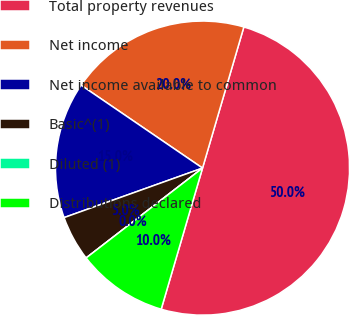<chart> <loc_0><loc_0><loc_500><loc_500><pie_chart><fcel>Total property revenues<fcel>Net income<fcel>Net income available to common<fcel>Basic^(1)<fcel>Diluted (1)<fcel>Distributions declared<nl><fcel>50.0%<fcel>20.0%<fcel>15.0%<fcel>5.0%<fcel>0.0%<fcel>10.0%<nl></chart> 